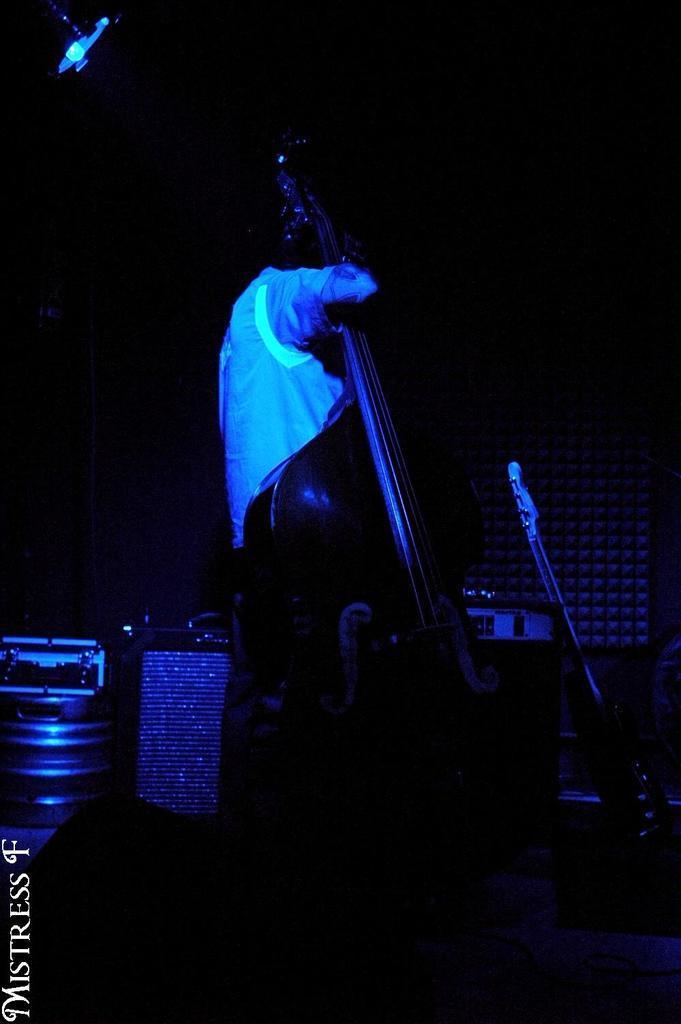Could you give a brief overview of what you see in this image? In the middle of the image, a person is standing and holding a guitar in his hand. On the left a focus light is visible. In the middle a table is there on which sound box is kept. The background is dark in color. This image is taken on the stage during night time. 